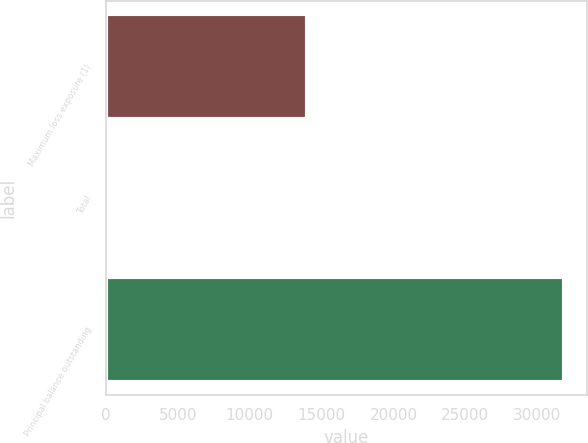Convert chart. <chart><loc_0><loc_0><loc_500><loc_500><bar_chart><fcel>Maximum loss exposure (1)<fcel>Total<fcel>Principal balance outstanding<nl><fcel>13947<fcel>163<fcel>31869<nl></chart> 